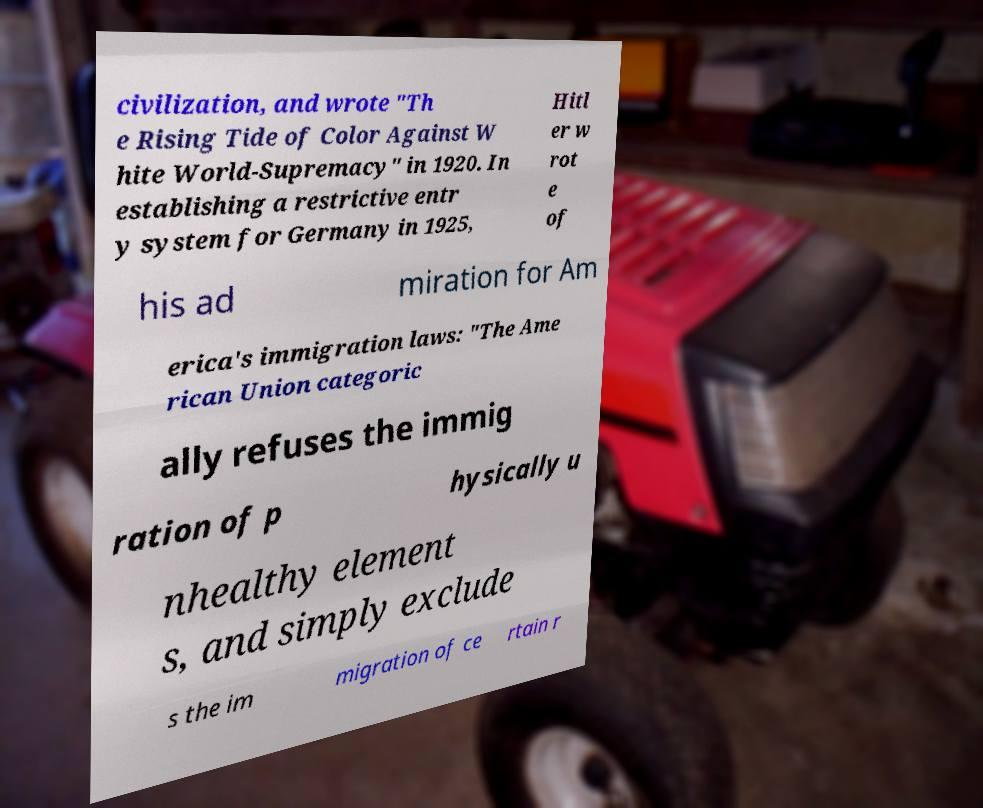There's text embedded in this image that I need extracted. Can you transcribe it verbatim? civilization, and wrote "Th e Rising Tide of Color Against W hite World-Supremacy" in 1920. In establishing a restrictive entr y system for Germany in 1925, Hitl er w rot e of his ad miration for Am erica's immigration laws: "The Ame rican Union categoric ally refuses the immig ration of p hysically u nhealthy element s, and simply exclude s the im migration of ce rtain r 